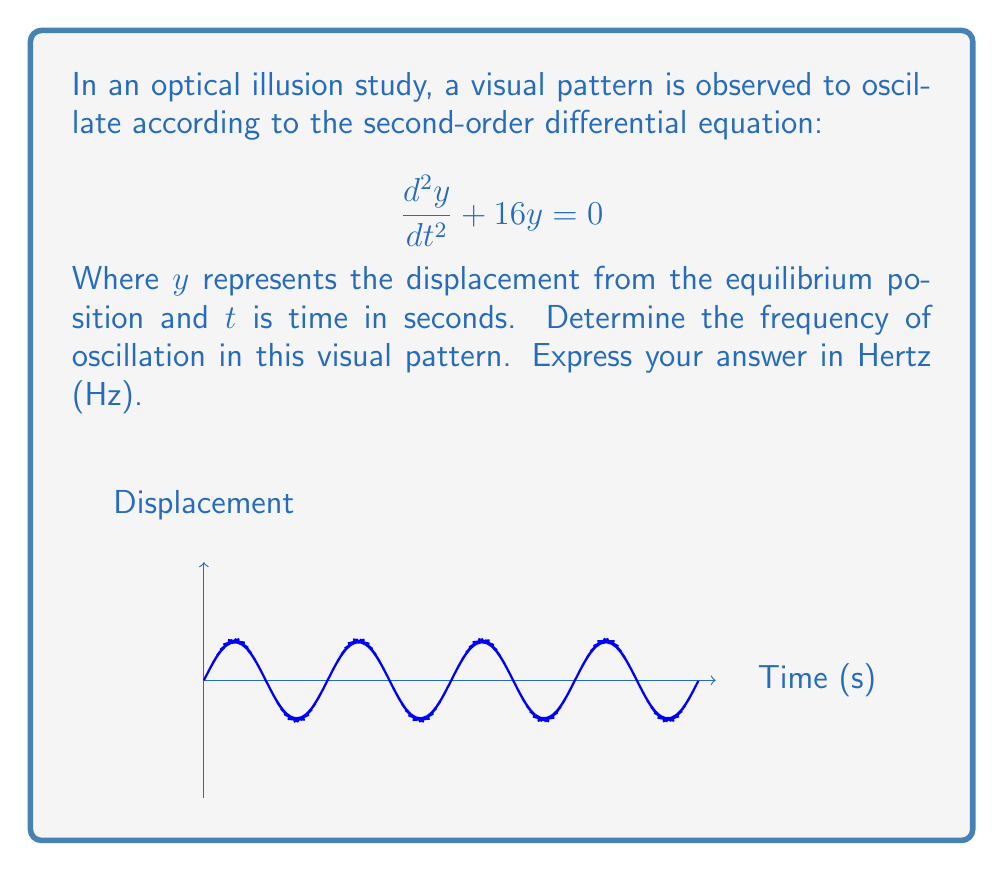Provide a solution to this math problem. To solve this problem, we'll follow these steps:

1) The general form of a second-order linear differential equation is:

   $$\frac{d^2y}{dt^2} + \omega^2y = 0$$

   Where $\omega$ is the angular frequency in radians per second.

2) Comparing our equation to the general form, we see that:

   $$\omega^2 = 16$$

3) Solve for $\omega$:

   $$\omega = \sqrt{16} = 4 \text{ rad/s}$$

4) The relationship between angular frequency $\omega$ and frequency $f$ in Hz is:

   $$\omega = 2\pi f$$

5) Substitute our value for $\omega$ and solve for $f$:

   $$4 = 2\pi f$$
   $$f = \frac{4}{2\pi} = \frac{2}{\pi} \approx 0.6366 \text{ Hz}$$

Therefore, the frequency of oscillation in this visual pattern is approximately 0.6366 Hz.
Answer: $\frac{2}{\pi}$ Hz 